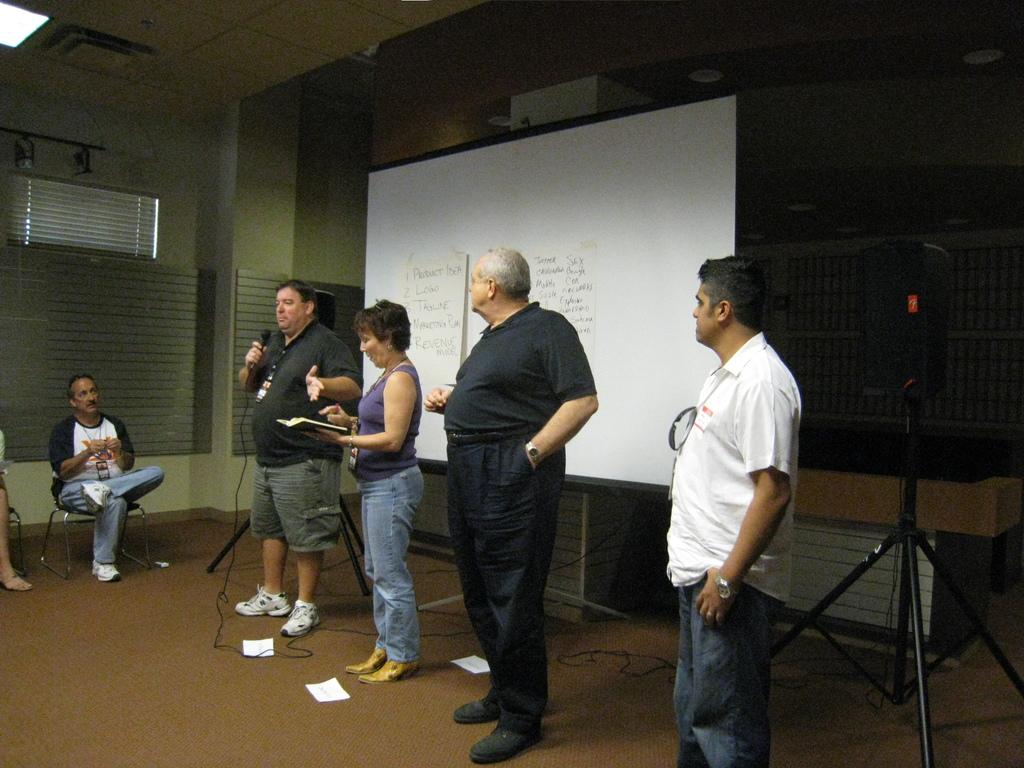What is the person in the image holding? The person is holding a microphone in the image. Where is the person standing? The person is standing on the floor. How are the other people in the image reacting to the person with the microphone? The other people are looking at the person with the microphone. What can be seen in the background of the image? There is a whiteboard in the background of the image. What type of crayon is the person using to draw on the tub in the image? There is no crayon or tub present in the image. What shape is the person drawing on the tub in the image? There is no shape being drawn on a tub in the image. 